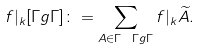Convert formula to latex. <formula><loc_0><loc_0><loc_500><loc_500>f | _ { k } [ \Gamma g \Gamma ] \colon = \sum _ { A \in \Gamma \ \Gamma g \Gamma } f | _ { k } \widetilde { A } .</formula> 